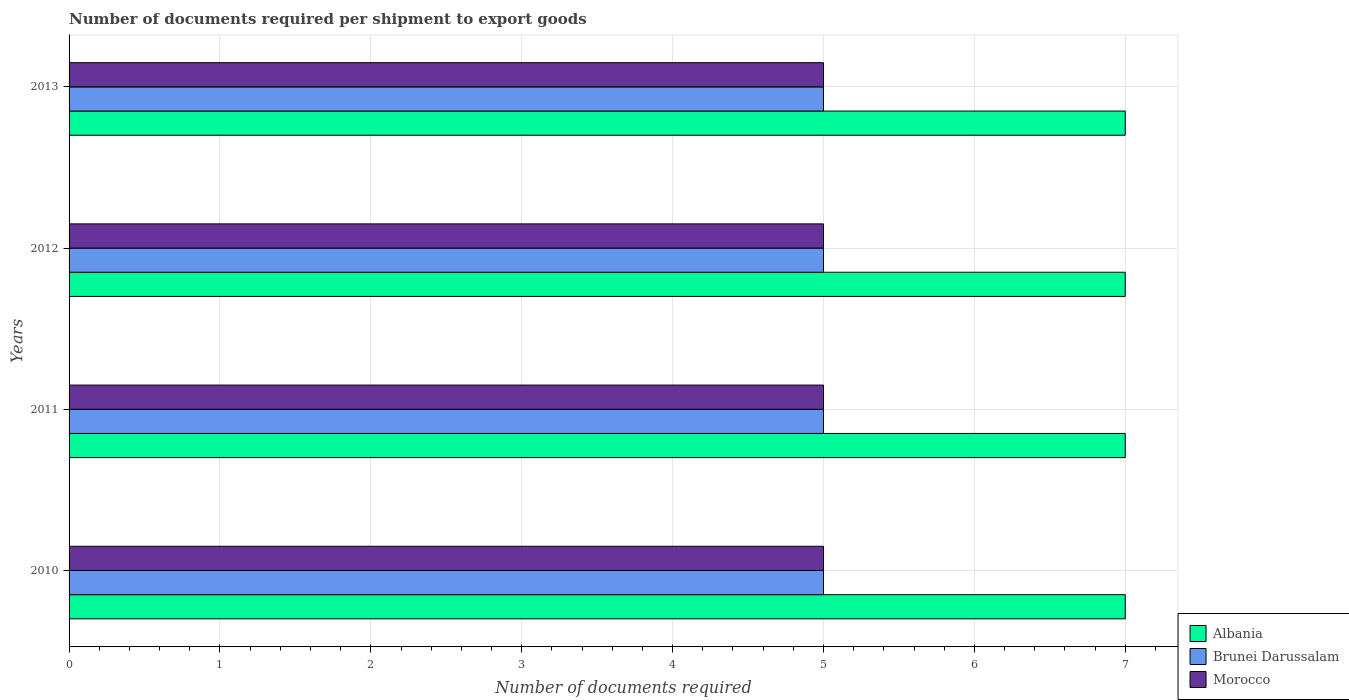How many different coloured bars are there?
Your response must be concise. 3. How many groups of bars are there?
Your answer should be compact. 4. Are the number of bars on each tick of the Y-axis equal?
Keep it short and to the point. Yes. How many bars are there on the 3rd tick from the top?
Make the answer very short. 3. What is the label of the 4th group of bars from the top?
Provide a succinct answer. 2010. What is the number of documents required per shipment to export goods in Morocco in 2012?
Make the answer very short. 5. Across all years, what is the maximum number of documents required per shipment to export goods in Brunei Darussalam?
Your answer should be compact. 5. Across all years, what is the minimum number of documents required per shipment to export goods in Albania?
Offer a terse response. 7. In which year was the number of documents required per shipment to export goods in Brunei Darussalam minimum?
Provide a short and direct response. 2010. What is the total number of documents required per shipment to export goods in Morocco in the graph?
Your answer should be very brief. 20. What is the difference between the number of documents required per shipment to export goods in Morocco in 2010 and the number of documents required per shipment to export goods in Albania in 2013?
Give a very brief answer. -2. What is the average number of documents required per shipment to export goods in Brunei Darussalam per year?
Make the answer very short. 5. In how many years, is the number of documents required per shipment to export goods in Morocco greater than 4 ?
Ensure brevity in your answer.  4. Is the number of documents required per shipment to export goods in Morocco in 2010 less than that in 2012?
Provide a succinct answer. No. Is the difference between the number of documents required per shipment to export goods in Morocco in 2010 and 2012 greater than the difference between the number of documents required per shipment to export goods in Brunei Darussalam in 2010 and 2012?
Give a very brief answer. No. What is the difference between the highest and the second highest number of documents required per shipment to export goods in Brunei Darussalam?
Provide a succinct answer. 0. Is the sum of the number of documents required per shipment to export goods in Albania in 2010 and 2011 greater than the maximum number of documents required per shipment to export goods in Brunei Darussalam across all years?
Offer a very short reply. Yes. What does the 3rd bar from the top in 2010 represents?
Keep it short and to the point. Albania. What does the 1st bar from the bottom in 2010 represents?
Offer a very short reply. Albania. How many bars are there?
Give a very brief answer. 12. How many years are there in the graph?
Provide a succinct answer. 4. Where does the legend appear in the graph?
Offer a terse response. Bottom right. How many legend labels are there?
Make the answer very short. 3. How are the legend labels stacked?
Your answer should be very brief. Vertical. What is the title of the graph?
Your answer should be very brief. Number of documents required per shipment to export goods. Does "Guinea-Bissau" appear as one of the legend labels in the graph?
Your answer should be compact. No. What is the label or title of the X-axis?
Offer a very short reply. Number of documents required. What is the label or title of the Y-axis?
Keep it short and to the point. Years. What is the Number of documents required in Albania in 2011?
Make the answer very short. 7. What is the Number of documents required of Brunei Darussalam in 2011?
Ensure brevity in your answer.  5. What is the Number of documents required in Morocco in 2011?
Offer a very short reply. 5. What is the Number of documents required in Brunei Darussalam in 2013?
Your answer should be very brief. 5. Across all years, what is the maximum Number of documents required in Albania?
Your answer should be very brief. 7. Across all years, what is the maximum Number of documents required of Brunei Darussalam?
Offer a terse response. 5. Across all years, what is the minimum Number of documents required in Brunei Darussalam?
Ensure brevity in your answer.  5. Across all years, what is the minimum Number of documents required of Morocco?
Give a very brief answer. 5. What is the total Number of documents required of Albania in the graph?
Provide a short and direct response. 28. What is the total Number of documents required of Brunei Darussalam in the graph?
Your response must be concise. 20. What is the difference between the Number of documents required of Morocco in 2010 and that in 2011?
Your answer should be compact. 0. What is the difference between the Number of documents required of Brunei Darussalam in 2010 and that in 2012?
Make the answer very short. 0. What is the difference between the Number of documents required of Brunei Darussalam in 2010 and that in 2013?
Your answer should be compact. 0. What is the difference between the Number of documents required of Brunei Darussalam in 2011 and that in 2012?
Keep it short and to the point. 0. What is the difference between the Number of documents required in Morocco in 2011 and that in 2012?
Keep it short and to the point. 0. What is the difference between the Number of documents required of Brunei Darussalam in 2011 and that in 2013?
Your answer should be very brief. 0. What is the difference between the Number of documents required in Albania in 2012 and that in 2013?
Ensure brevity in your answer.  0. What is the difference between the Number of documents required of Albania in 2010 and the Number of documents required of Brunei Darussalam in 2012?
Your response must be concise. 2. What is the difference between the Number of documents required of Brunei Darussalam in 2010 and the Number of documents required of Morocco in 2012?
Provide a short and direct response. 0. What is the difference between the Number of documents required of Brunei Darussalam in 2011 and the Number of documents required of Morocco in 2012?
Provide a short and direct response. 0. What is the difference between the Number of documents required of Albania in 2011 and the Number of documents required of Morocco in 2013?
Provide a short and direct response. 2. What is the difference between the Number of documents required in Brunei Darussalam in 2012 and the Number of documents required in Morocco in 2013?
Provide a short and direct response. 0. In the year 2010, what is the difference between the Number of documents required of Brunei Darussalam and Number of documents required of Morocco?
Give a very brief answer. 0. In the year 2011, what is the difference between the Number of documents required in Brunei Darussalam and Number of documents required in Morocco?
Provide a succinct answer. 0. In the year 2012, what is the difference between the Number of documents required of Albania and Number of documents required of Brunei Darussalam?
Your answer should be compact. 2. In the year 2012, what is the difference between the Number of documents required of Albania and Number of documents required of Morocco?
Provide a short and direct response. 2. In the year 2012, what is the difference between the Number of documents required of Brunei Darussalam and Number of documents required of Morocco?
Provide a succinct answer. 0. In the year 2013, what is the difference between the Number of documents required of Albania and Number of documents required of Brunei Darussalam?
Provide a succinct answer. 2. In the year 2013, what is the difference between the Number of documents required of Albania and Number of documents required of Morocco?
Give a very brief answer. 2. In the year 2013, what is the difference between the Number of documents required in Brunei Darussalam and Number of documents required in Morocco?
Make the answer very short. 0. What is the ratio of the Number of documents required in Albania in 2010 to that in 2011?
Your response must be concise. 1. What is the ratio of the Number of documents required in Brunei Darussalam in 2010 to that in 2011?
Ensure brevity in your answer.  1. What is the ratio of the Number of documents required in Morocco in 2010 to that in 2011?
Provide a short and direct response. 1. What is the ratio of the Number of documents required of Albania in 2010 to that in 2012?
Keep it short and to the point. 1. What is the ratio of the Number of documents required in Morocco in 2010 to that in 2012?
Make the answer very short. 1. What is the ratio of the Number of documents required in Brunei Darussalam in 2010 to that in 2013?
Make the answer very short. 1. What is the ratio of the Number of documents required in Albania in 2011 to that in 2012?
Ensure brevity in your answer.  1. What is the ratio of the Number of documents required of Brunei Darussalam in 2011 to that in 2012?
Give a very brief answer. 1. What is the ratio of the Number of documents required of Morocco in 2011 to that in 2012?
Your answer should be very brief. 1. What is the ratio of the Number of documents required of Brunei Darussalam in 2011 to that in 2013?
Provide a short and direct response. 1. What is the ratio of the Number of documents required of Morocco in 2011 to that in 2013?
Provide a short and direct response. 1. What is the ratio of the Number of documents required of Brunei Darussalam in 2012 to that in 2013?
Keep it short and to the point. 1. What is the ratio of the Number of documents required in Morocco in 2012 to that in 2013?
Keep it short and to the point. 1. What is the difference between the highest and the second highest Number of documents required in Brunei Darussalam?
Keep it short and to the point. 0. 